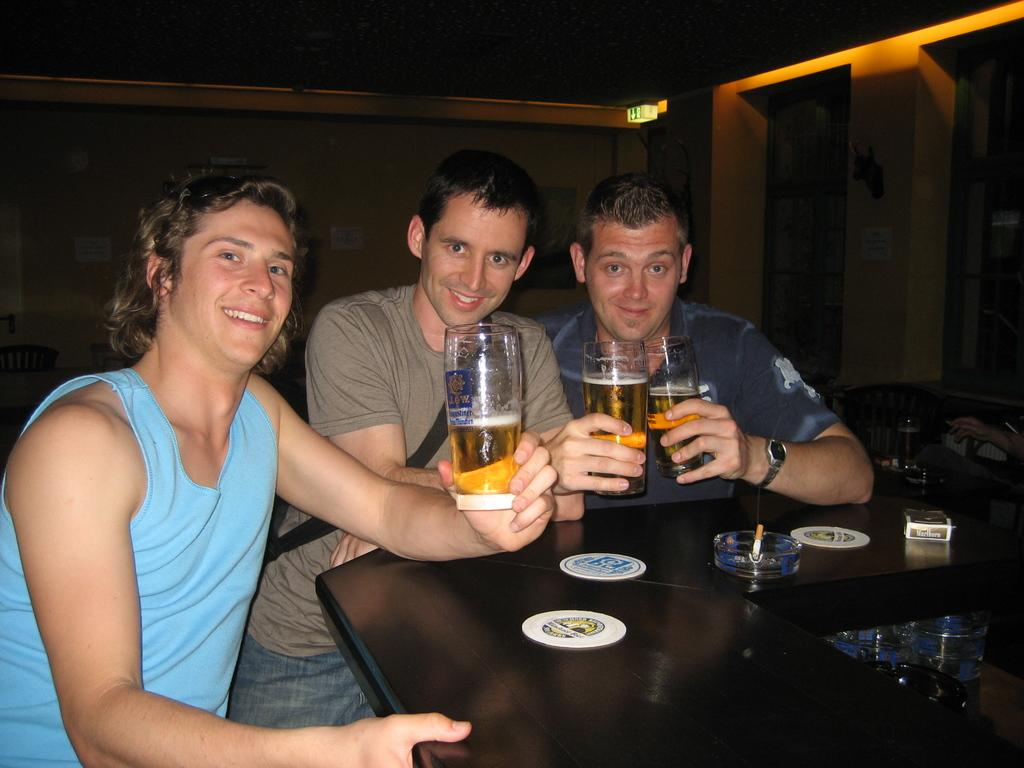How many people are in the image? There are three persons in the middle of the image. What objects can be seen in the image besides the people? There are glasses and a table visible in the image. What is in the background of the image? There is a wall in the background of the image. What type of light source is present in the image? There is a light in the image. What type of wristwatch is the person on the left wearing in the image? There is no wristwatch visible on any of the persons in the image. 